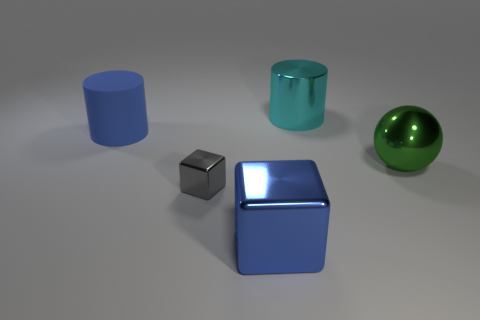Subtract all blue blocks. How many blocks are left? 1 Add 3 big cyan metallic objects. How many objects exist? 8 Subtract all brown balls. Subtract all cyan cylinders. How many balls are left? 1 Subtract all yellow rubber spheres. Subtract all large green shiny balls. How many objects are left? 4 Add 3 small gray objects. How many small gray objects are left? 4 Add 3 cyan things. How many cyan things exist? 4 Subtract 0 purple cylinders. How many objects are left? 5 Subtract all balls. How many objects are left? 4 